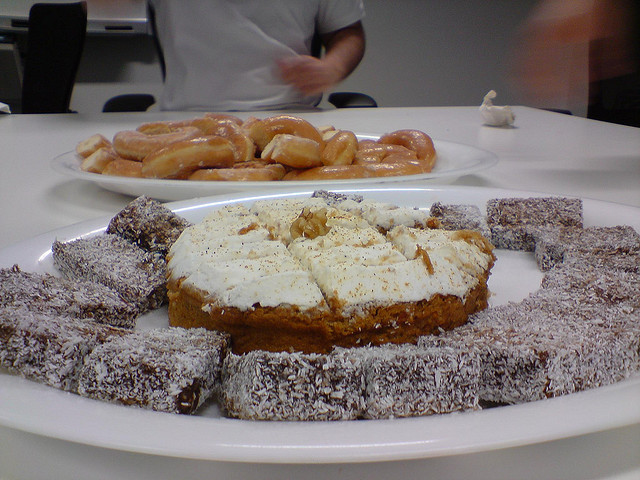<image>What is the hand reaching for? I am not sure. The hand could be reaching for a variety of items such as food, a napkin, or a donut. What is the hand reaching for? I don't know what the hand is reaching for. It can be seen reaching for food, napkin, donut, or book. 